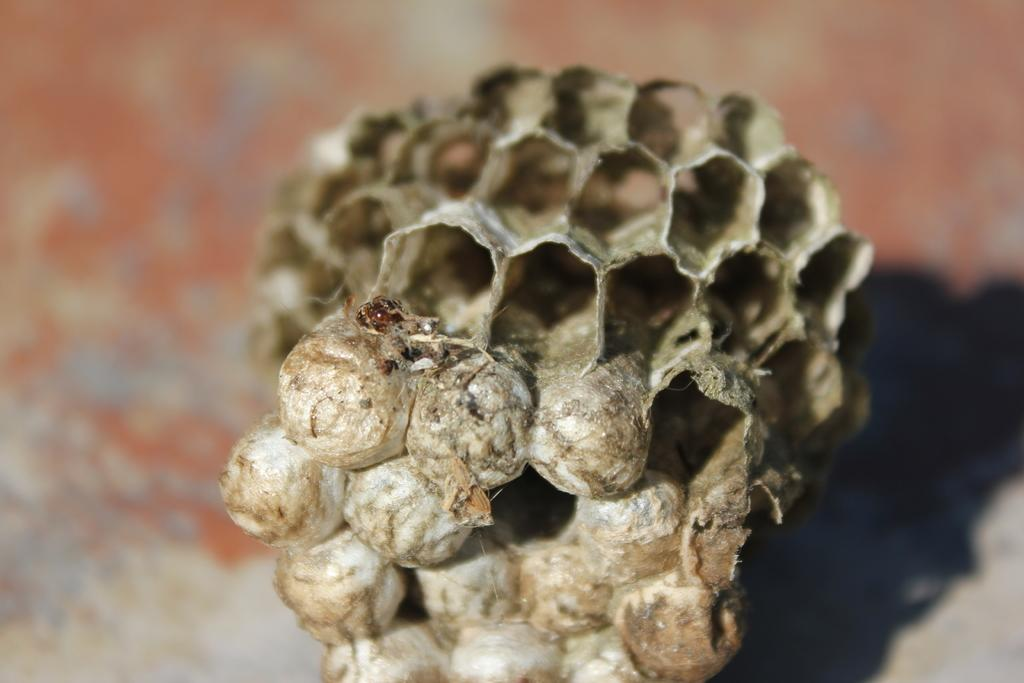What type of object is present in the image? The image contains a dry honeycomb. What color is the honeycomb? The honeycomb is in grey color. Can you describe the background of the image? The background of the image is blurred. What type of note is attached to the honeycomb in the image? There is no note attached to the honeycomb in the image. What kind of bait is used to attract bees to the honeycomb in the image? There is no bait present in the image, as it only contains a dry honeycomb. 